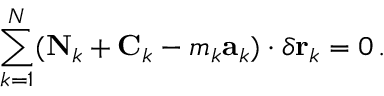Convert formula to latex. <formula><loc_0><loc_0><loc_500><loc_500>\sum _ { k = 1 } ^ { N } ( N _ { k } + C _ { k } - m _ { k } a _ { k } ) \cdot \delta r _ { k } = 0 \, .</formula> 